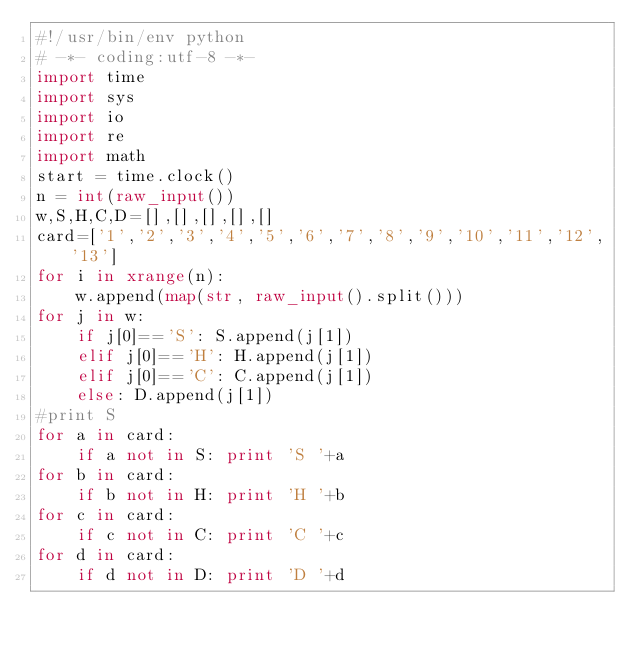Convert code to text. <code><loc_0><loc_0><loc_500><loc_500><_Python_>#!/usr/bin/env python
# -*- coding:utf-8 -*-
import time
import sys
import io
import re
import math
start = time.clock()
n = int(raw_input())
w,S,H,C,D=[],[],[],[],[]
card=['1','2','3','4','5','6','7','8','9','10','11','12','13']
for i in xrange(n):
    w.append(map(str, raw_input().split()))
for j in w:
    if j[0]=='S': S.append(j[1])
    elif j[0]=='H': H.append(j[1])
    elif j[0]=='C': C.append(j[1])
    else: D.append(j[1])
#print S
for a in card:
    if a not in S: print 'S '+a
for b in card:
    if b not in H: print 'H '+b
for c in card:
    if c not in C: print 'C '+c
for d in card:
    if d not in D: print 'D '+d</code> 